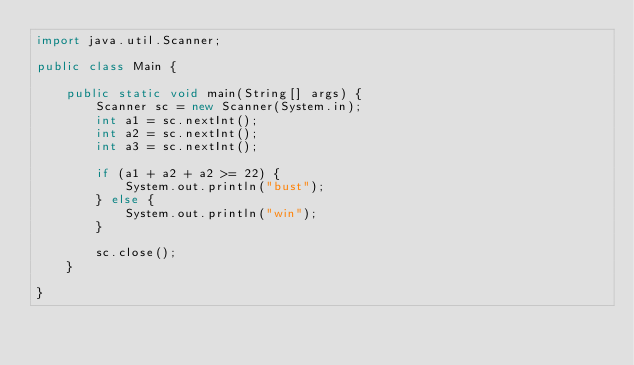<code> <loc_0><loc_0><loc_500><loc_500><_Java_>import java.util.Scanner;

public class Main {

    public static void main(String[] args) {
        Scanner sc = new Scanner(System.in);
        int a1 = sc.nextInt();
        int a2 = sc.nextInt();
        int a3 = sc.nextInt();

        if (a1 + a2 + a2 >= 22) {
            System.out.println("bust");
        } else {
            System.out.println("win");
        }

        sc.close();
    }

}
</code> 